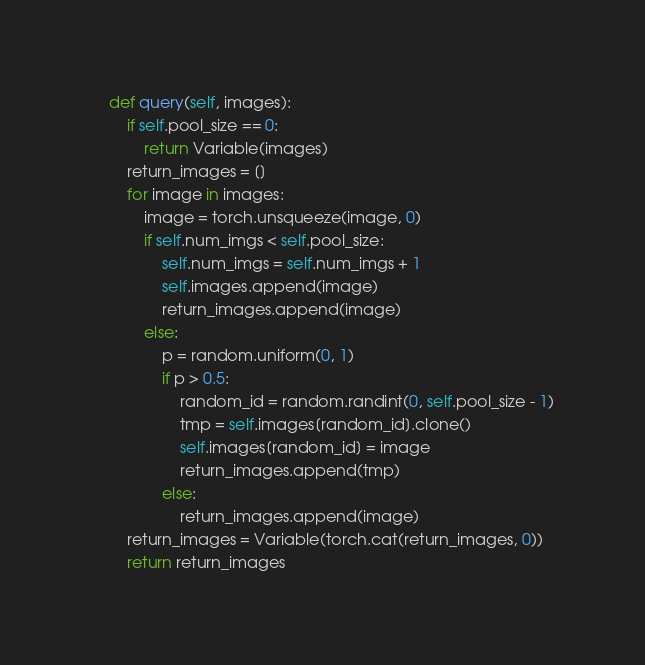<code> <loc_0><loc_0><loc_500><loc_500><_Python_>    def query(self, images):
        if self.pool_size == 0:
            return Variable(images)
        return_images = []
        for image in images:
            image = torch.unsqueeze(image, 0)
            if self.num_imgs < self.pool_size:
                self.num_imgs = self.num_imgs + 1
                self.images.append(image)
                return_images.append(image)
            else:
                p = random.uniform(0, 1)
                if p > 0.5:
                    random_id = random.randint(0, self.pool_size - 1)
                    tmp = self.images[random_id].clone()
                    self.images[random_id] = image
                    return_images.append(tmp)
                else:
                    return_images.append(image)
        return_images = Variable(torch.cat(return_images, 0))
        return return_images
</code> 